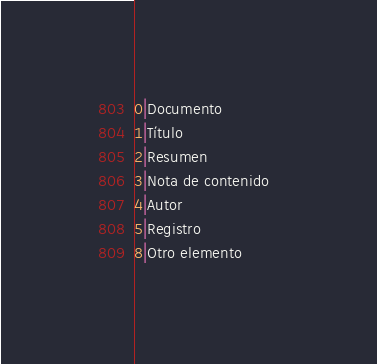<code> <loc_0><loc_0><loc_500><loc_500><_SQL_>0|Documento  
1|Título
2|Resumen 
3|Nota de contenido  
4|Autor  
5|Registro 
8|Otro elemento  </code> 